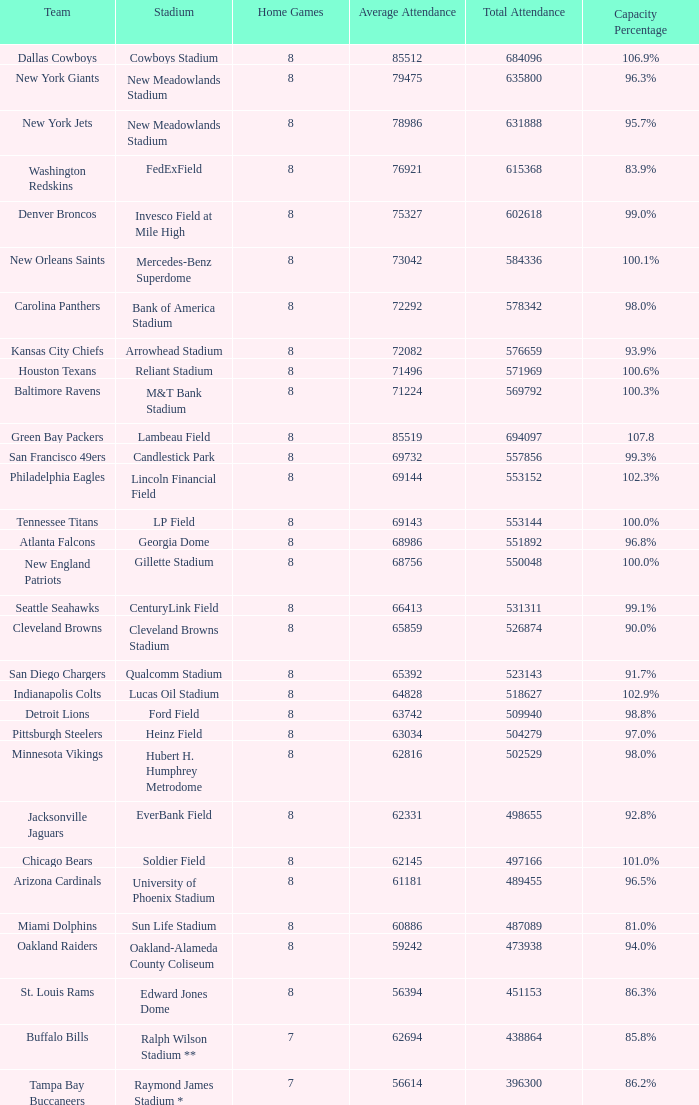How many home games are listed when the average attendance is 79475? 1.0. 